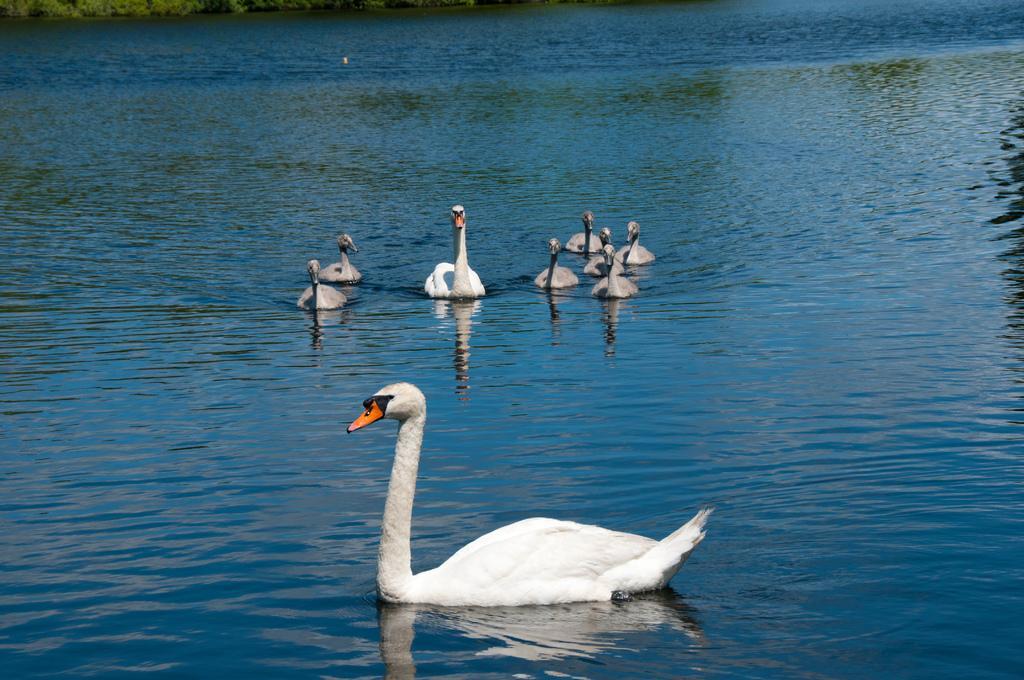How would you summarize this image in a sentence or two? In this picture there is a duck on the water at the bottom side of the image and there are other ducks on the water in the center of the image and there is greenery at the top side of the image. 